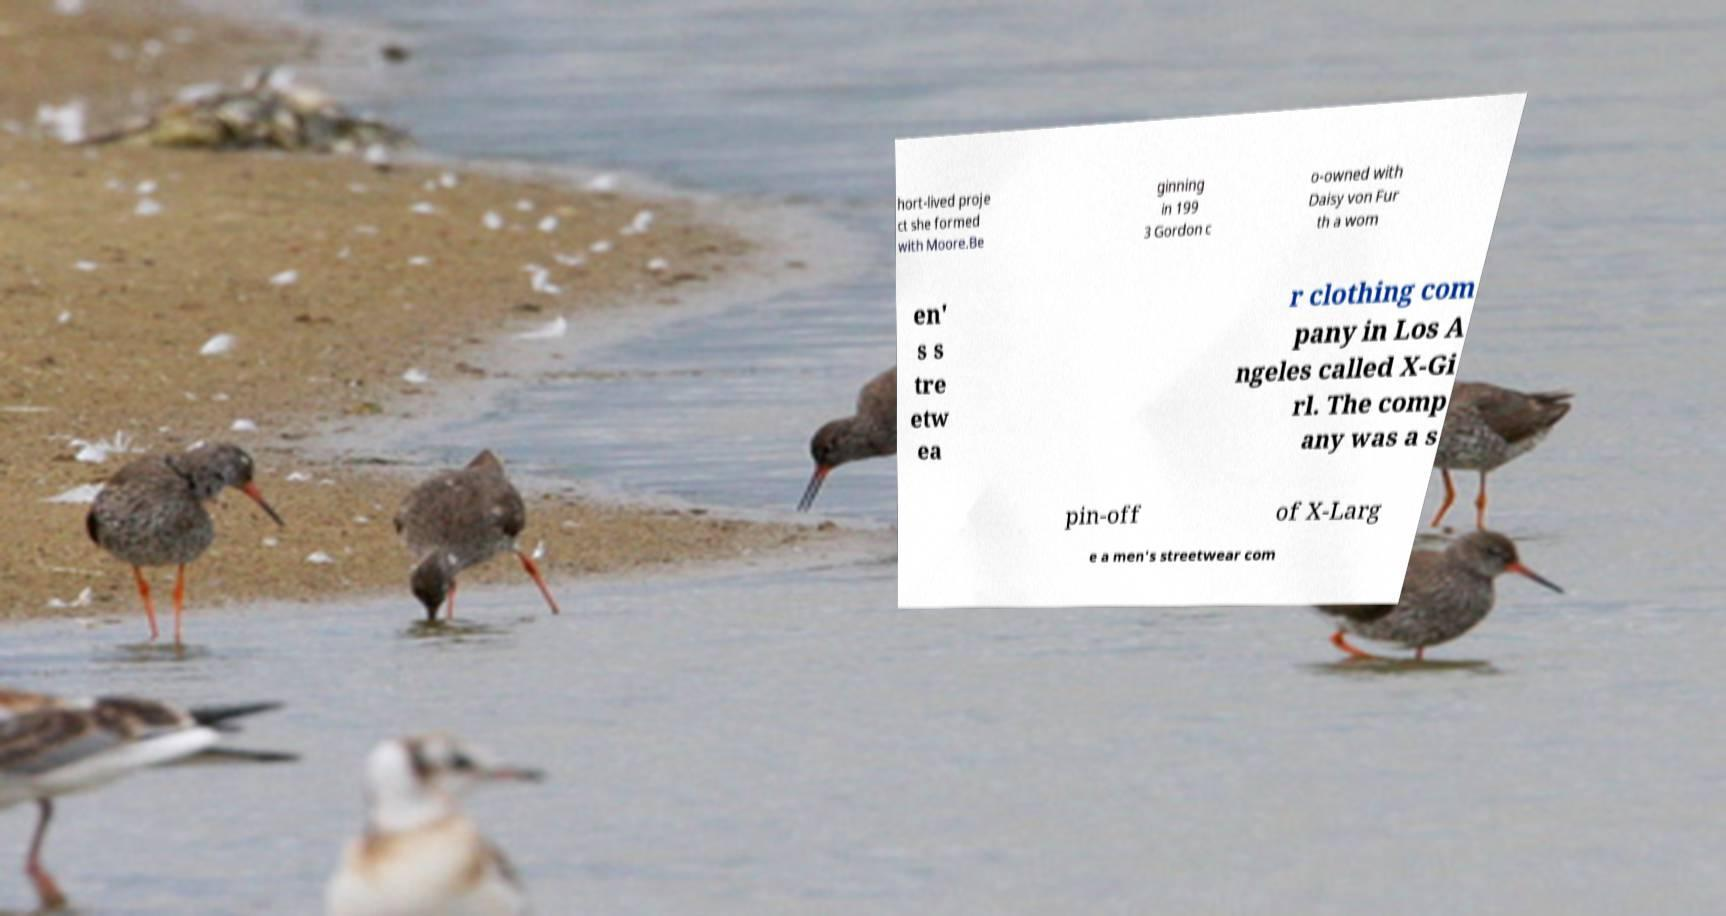What messages or text are displayed in this image? I need them in a readable, typed format. hort-lived proje ct she formed with Moore.Be ginning in 199 3 Gordon c o-owned with Daisy von Fur th a wom en' s s tre etw ea r clothing com pany in Los A ngeles called X-Gi rl. The comp any was a s pin-off of X-Larg e a men's streetwear com 